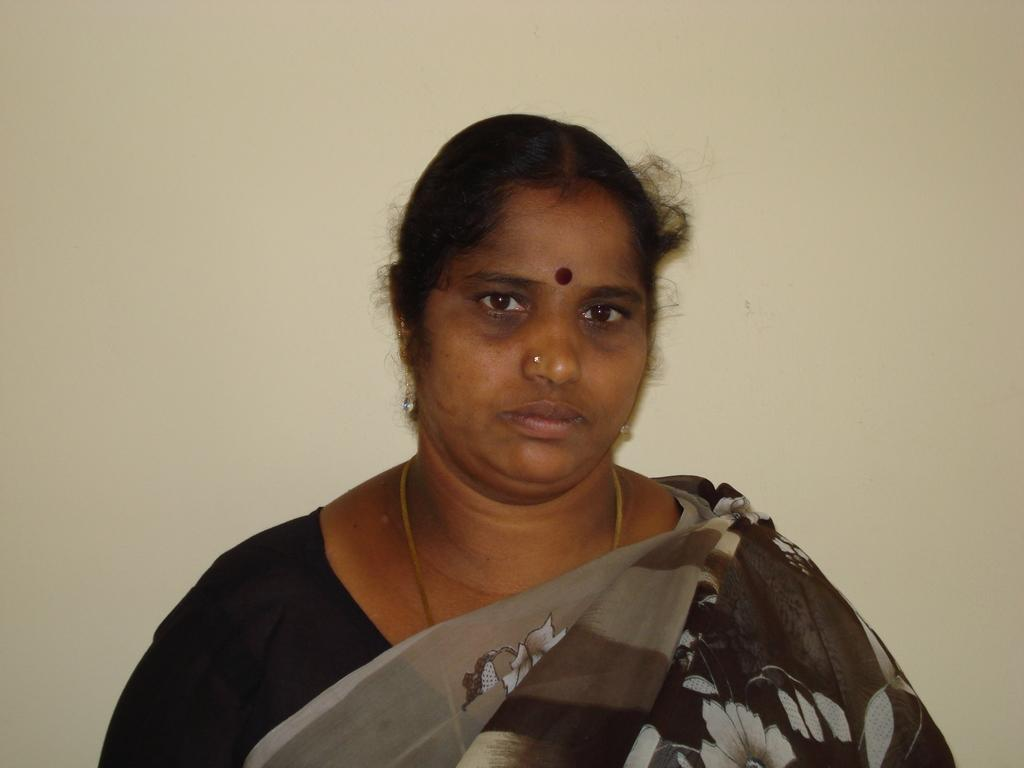Who is the main subject in the image? There is a lady in the image. What is the lady wearing? The lady is wearing a saree. What can be seen in the background of the image? There is a wall in the background of the image. What type of berry is the lady holding in the image? There is no berry present in the image; the lady is wearing a saree and standing in front of a wall. 